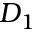Convert formula to latex. <formula><loc_0><loc_0><loc_500><loc_500>D _ { 1 }</formula> 